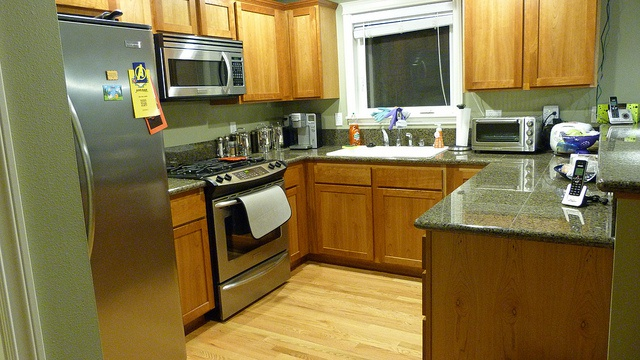Describe the objects in this image and their specific colors. I can see refrigerator in gray, maroon, olive, and darkgray tones, oven in gray, black, olive, darkgray, and maroon tones, microwave in gray, black, darkgray, and darkgreen tones, oven in gray, black, darkgray, and olive tones, and sink in gray, white, beige, and darkgray tones in this image. 